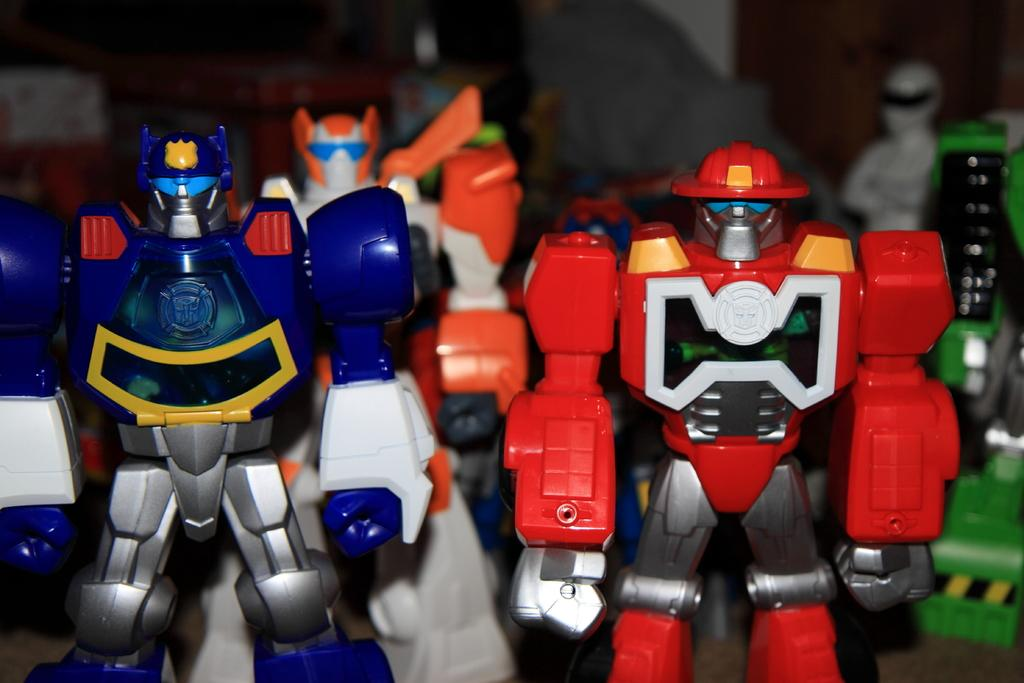What type of toys are featured in the image? There are robot toys in the image. Can you describe the appearance of the robot toys? The robot toys have different colors. What can be observed about the background of the image? The background of the image appears blurry. Can you tell me how the robot toys are fueled in the image? There is no information about the robot toys' fuel source in the image. 